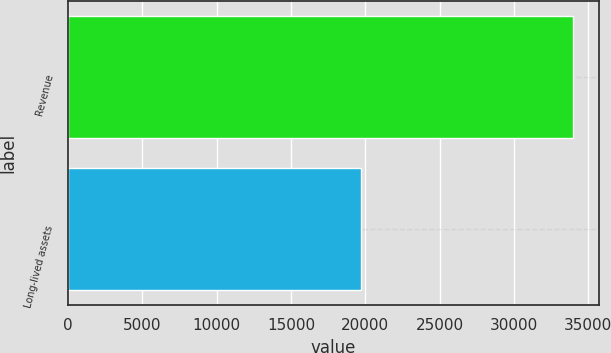Convert chart to OTSL. <chart><loc_0><loc_0><loc_500><loc_500><bar_chart><fcel>Revenue<fcel>Long-lived assets<nl><fcel>33987<fcel>19704<nl></chart> 